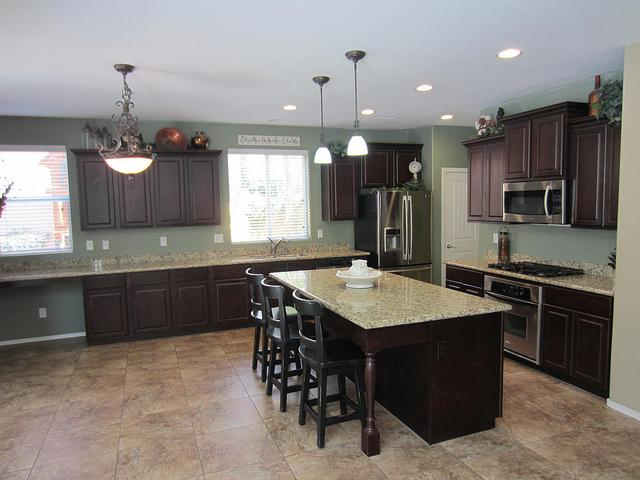What is the right side of the room mainly used for? Please explain your reasoning. cooking. There is a stove near the right side of the kitchen. 